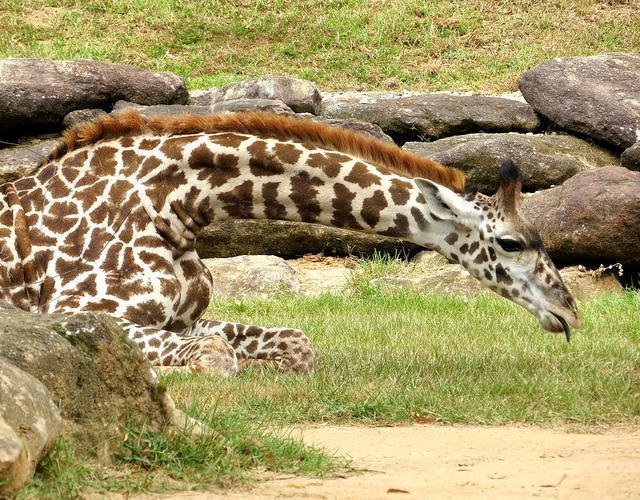How many people are wearing a hat?
Give a very brief answer. 0. 